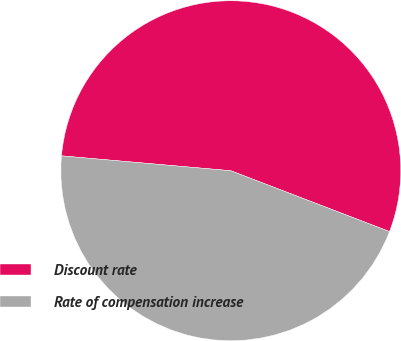<chart> <loc_0><loc_0><loc_500><loc_500><pie_chart><fcel>Discount rate<fcel>Rate of compensation increase<nl><fcel>54.43%<fcel>45.57%<nl></chart> 